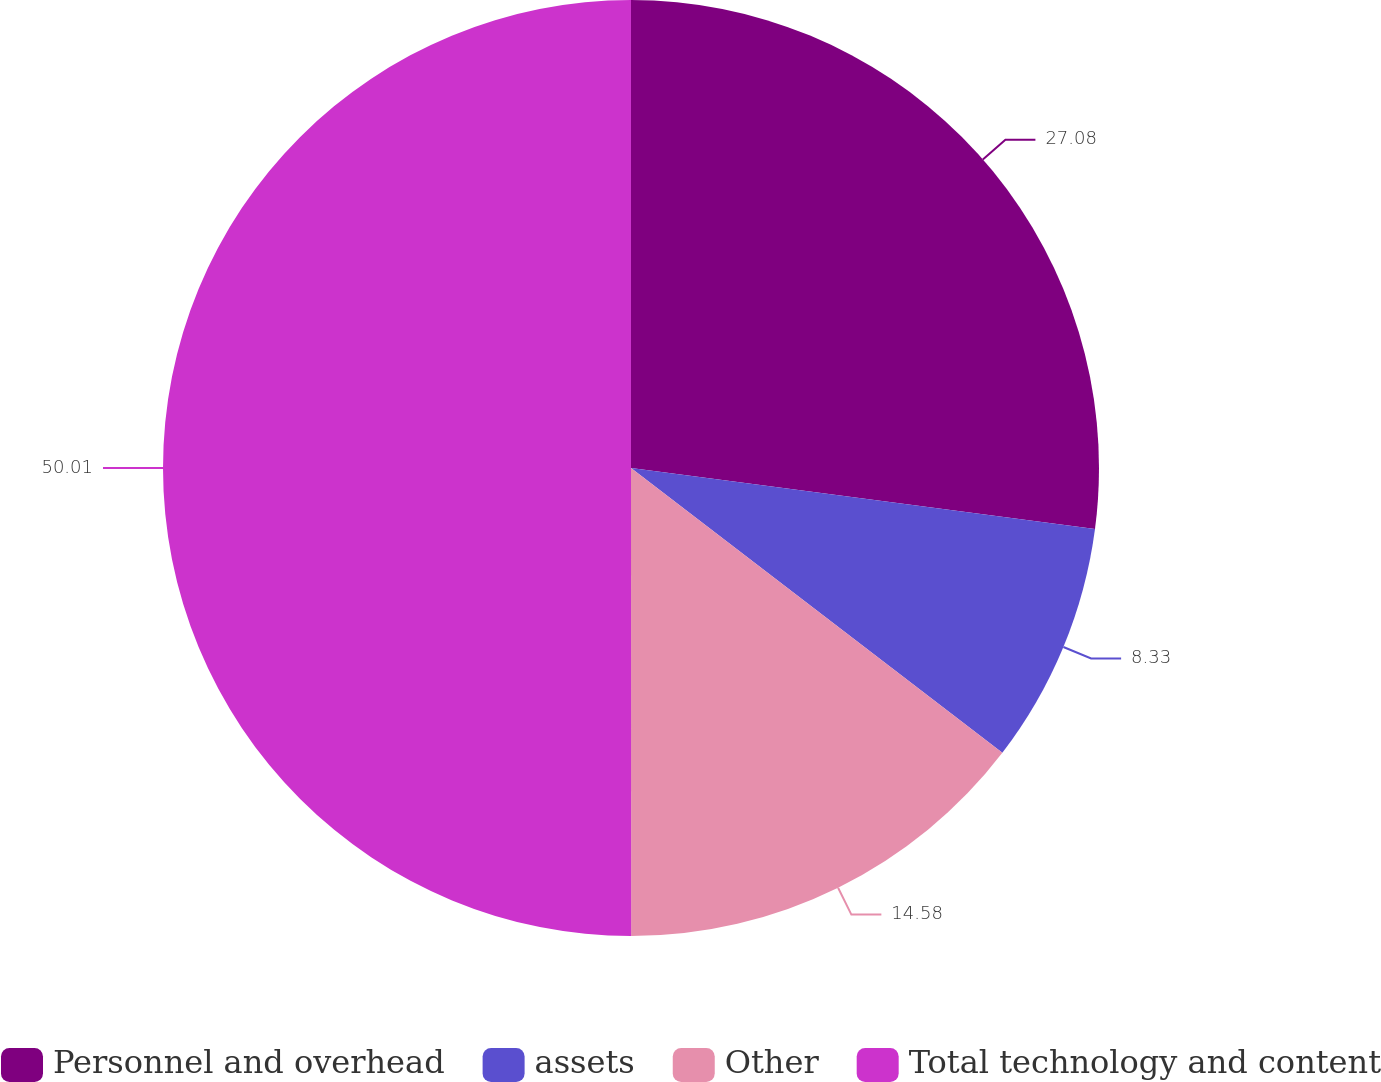<chart> <loc_0><loc_0><loc_500><loc_500><pie_chart><fcel>Personnel and overhead<fcel>assets<fcel>Other<fcel>Total technology and content<nl><fcel>27.08%<fcel>8.33%<fcel>14.58%<fcel>50.0%<nl></chart> 